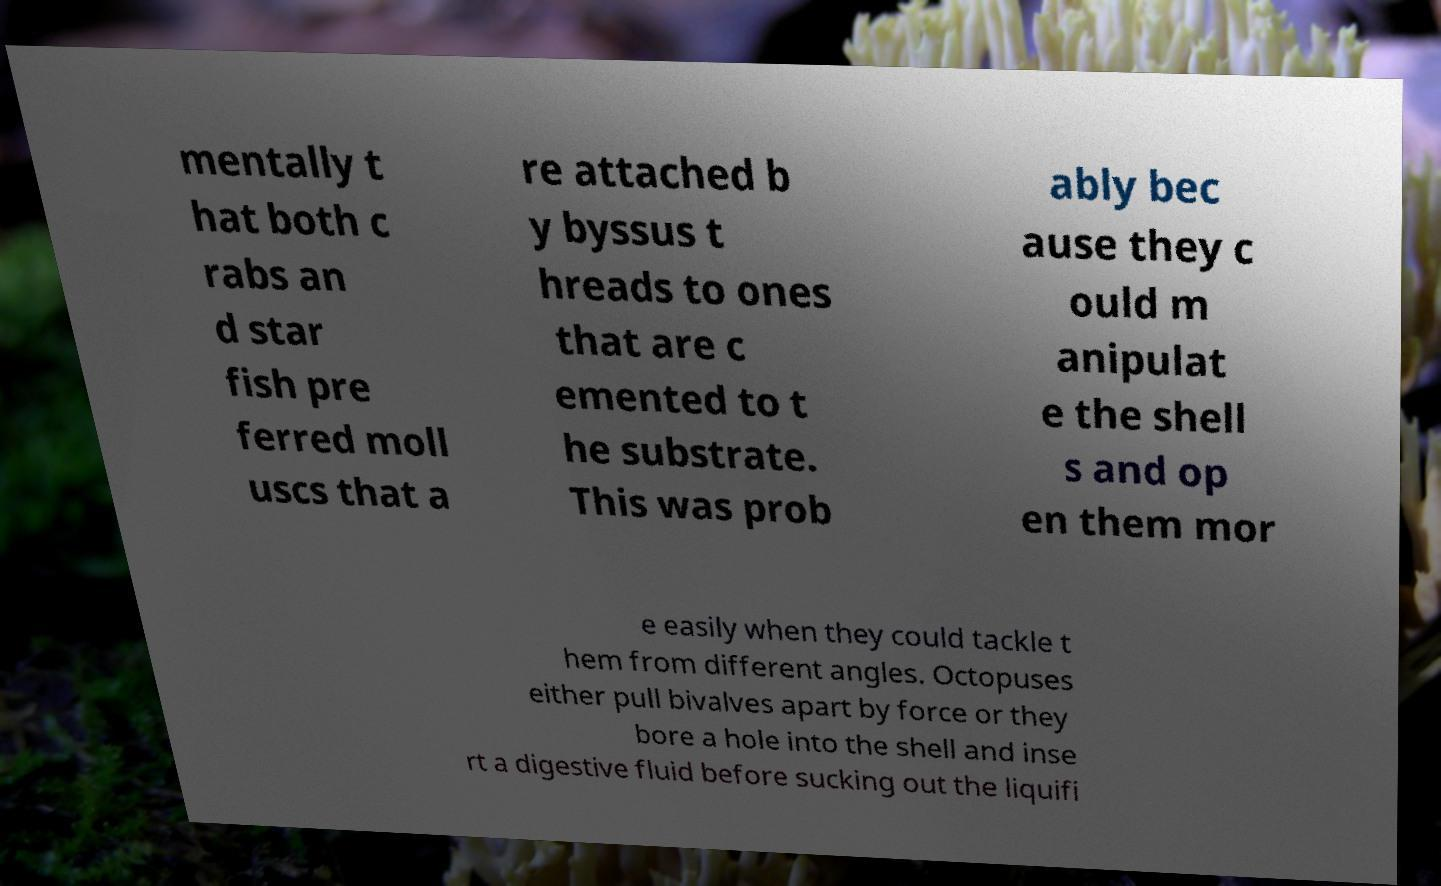I need the written content from this picture converted into text. Can you do that? mentally t hat both c rabs an d star fish pre ferred moll uscs that a re attached b y byssus t hreads to ones that are c emented to t he substrate. This was prob ably bec ause they c ould m anipulat e the shell s and op en them mor e easily when they could tackle t hem from different angles. Octopuses either pull bivalves apart by force or they bore a hole into the shell and inse rt a digestive fluid before sucking out the liquifi 